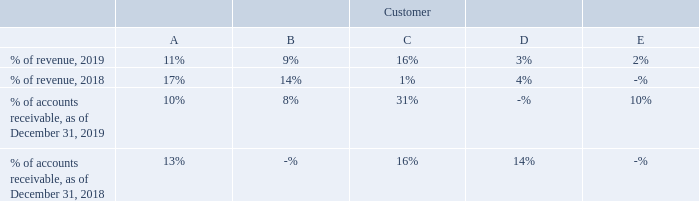NOTE 6. ACCOUNTS RECEIVABLE AND REVENUES
Amounts billed and due from our customers are classified as accounts receivables on our consolidated balance sheets and require
payment on a short-term basis. Invoices are generally issued at the point control transfers and substantially all of our invoices are due
within 30 days or less, however certain customers have terms of up to 120 days. For substantially all of our contracts, control of the
ordered product(s) transfers at our location. Periodically, we require payment prior to the point in time we recognize revenue. Amounts
received from customers prior to revenue recognition on a contract are contract liabilities, are classified as customer prepayments liability on our consolidated balance sheets and are typically applied to an invoice within 30 days of the prepayment. Revenues in 2019 include $0.1 million in unearned revenue as of December 31, 2018, and in 2018 include less than $0.1 million in unearned revenue as of
January 1, 2018.
Our accounts receivable potentially subject us to significant concentrations of credit risk. Revenues and accounts receivable from significant customers (customers with revenue or accounts receivable in excess of 10% of consolidated totals) are stated below as a percent of consolidated totals.
What are the respective accounts receivables as a percentage of revenue from customers A and B in 2019? 11%, 9%. What are the respective accounts receivables as a percentage of revenue from customers B and C in 2019? 9%, 16%. What are the respective accounts receivables as a percentage of revenue from customers C and D in 2019? 16%, 3%. What is the change in the amount of accounts receivable as a percentage of revenue from customer A between 2018 and 2019? 11 - 17 
Answer: -6. What is the change in the amount of accounts receivable as a percentage of revenue from customer B between 2018 and 2019? 9 - 14 
Answer: -5. What is the change in the amount of accounts receivable as a percentage of revenue from customer C between 2018 and 2019? 16 - 1 
Answer: 15. 